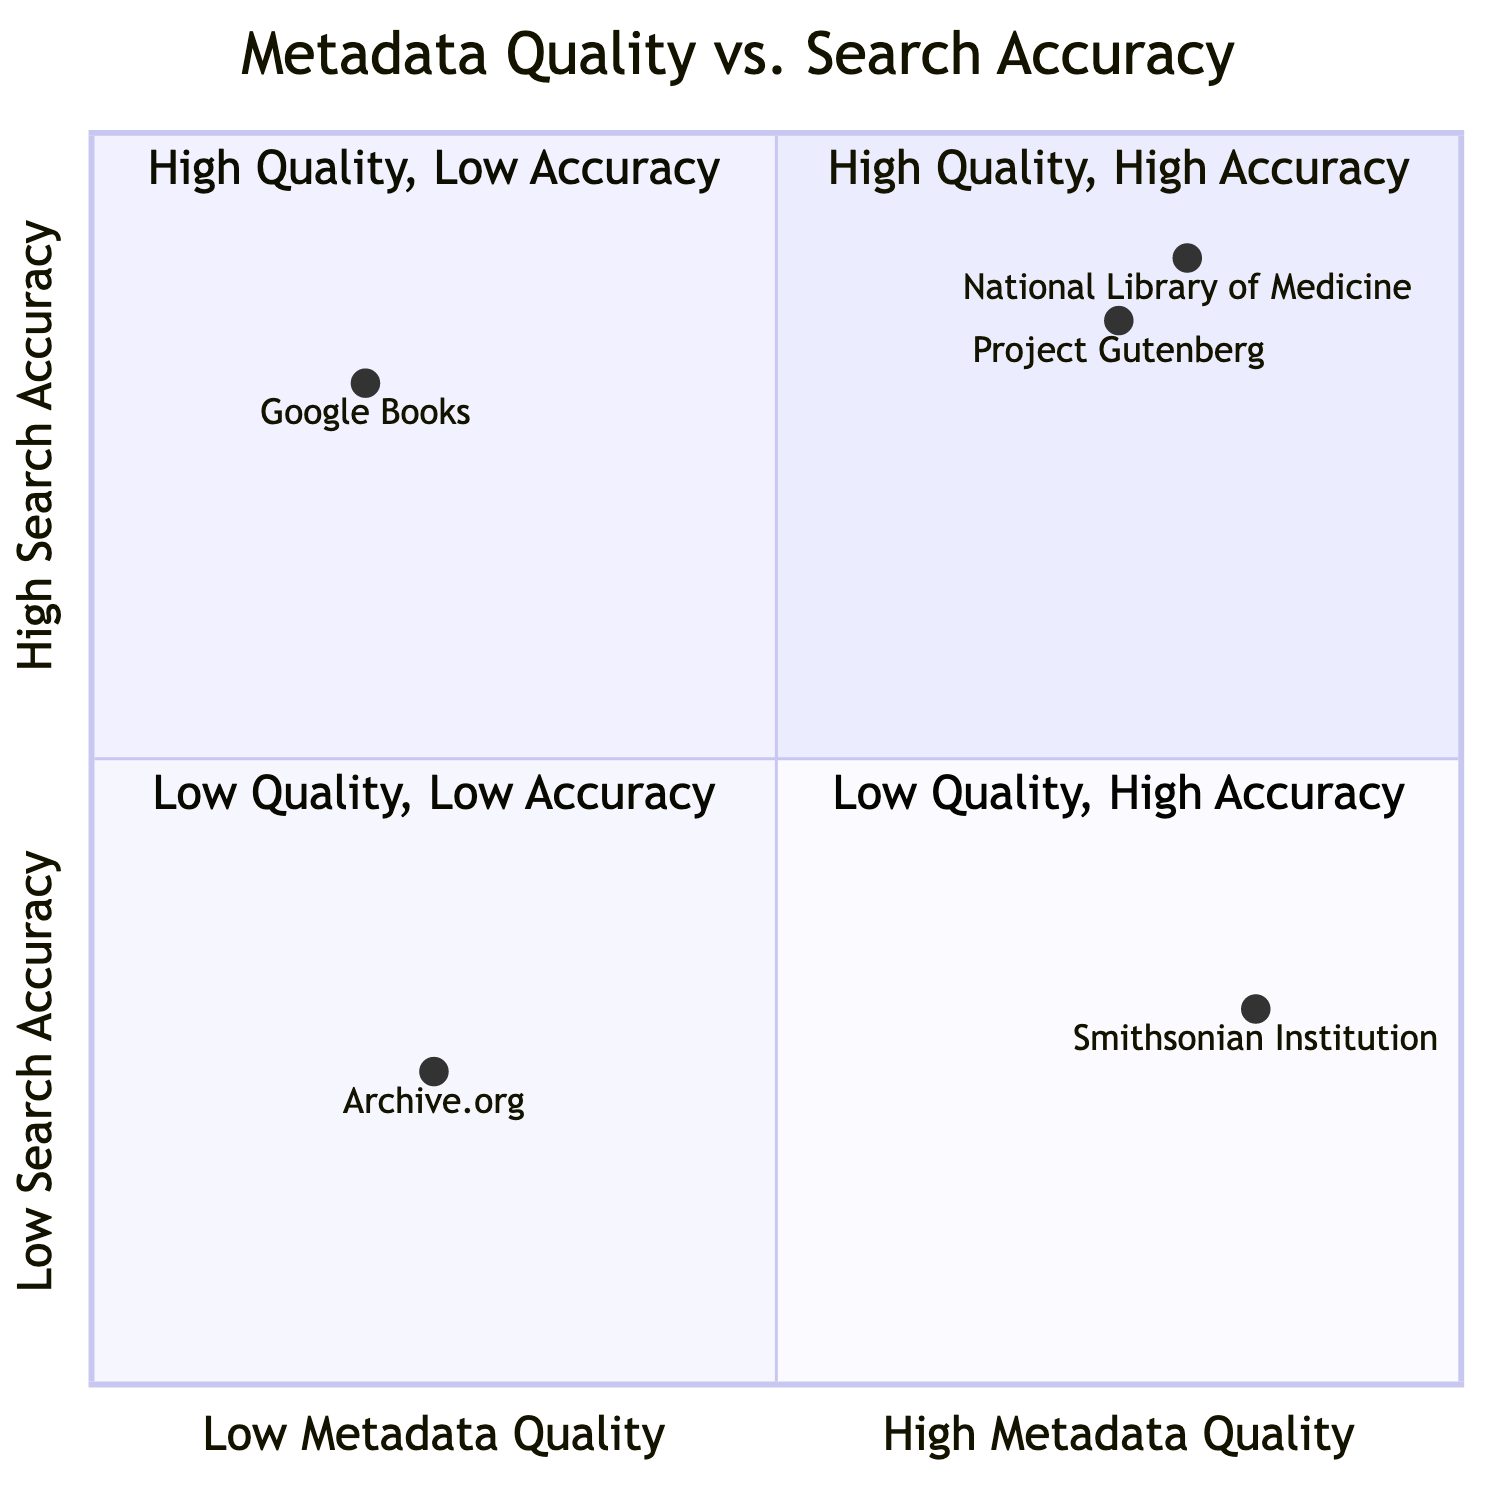What organizations are in the "High Metadata Quality / High Search Accuracy" quadrant? The quadrant labeled "High Metadata Quality / High Search Accuracy" contains the organizations National Library of Medicine and Project Gutenberg.
Answer: National Library of Medicine, Project Gutenberg Which organization has high metadata quality but low search accuracy? The organization positioned in the "High Metadata Quality / Low Search Accuracy" quadrant is the Smithsonian Institution.
Answer: Smithsonian Institution How many organizations are in the "Low Metadata Quality / Low Search Accuracy" quadrant? There is one organization located in the "Low Metadata Quality / Low Search Accuracy" quadrant, which is Archive.org.
Answer: 1 What is the search accuracy value of Google Books? To find the search accuracy of Google Books, we look at its coordinates which indicate a search accuracy of 0.8 in the "Low Metadata Quality / High Search Accuracy" quadrant.
Answer: 0.8 Which quadrant contains the Smithsonian Institution? The Smithsonian Institution is in the "High Metadata Quality / Low Search Accuracy" quadrant.
Answer: High Metadata Quality / Low Search Accuracy Name an organization with low metadata quality that has high search accuracy. Google Books is the organization with low metadata quality that is positioned in the quadrant of "Low Metadata Quality / High Search Accuracy."
Answer: Google Books In which quadrant is Archive.org located? Archive.org is located in the "Low Metadata Quality / Low Search Accuracy" quadrant.
Answer: Low Metadata Quality / Low Search Accuracy What is the metadata quality of Project Gutenberg? Project Gutenberg has a metadata quality value of 0.75, placing it in the "High Metadata Quality / High Search Accuracy" quadrant.
Answer: 0.75 How does the search accuracy of the Smithsonian Institution compare to that of Google Books? The Smithsonian Institution has a search accuracy of 0.3, while Google Books has a search accuracy of 0.8, indicating that Google Books has a higher search accuracy.
Answer: Google Books has higher search accuracy 